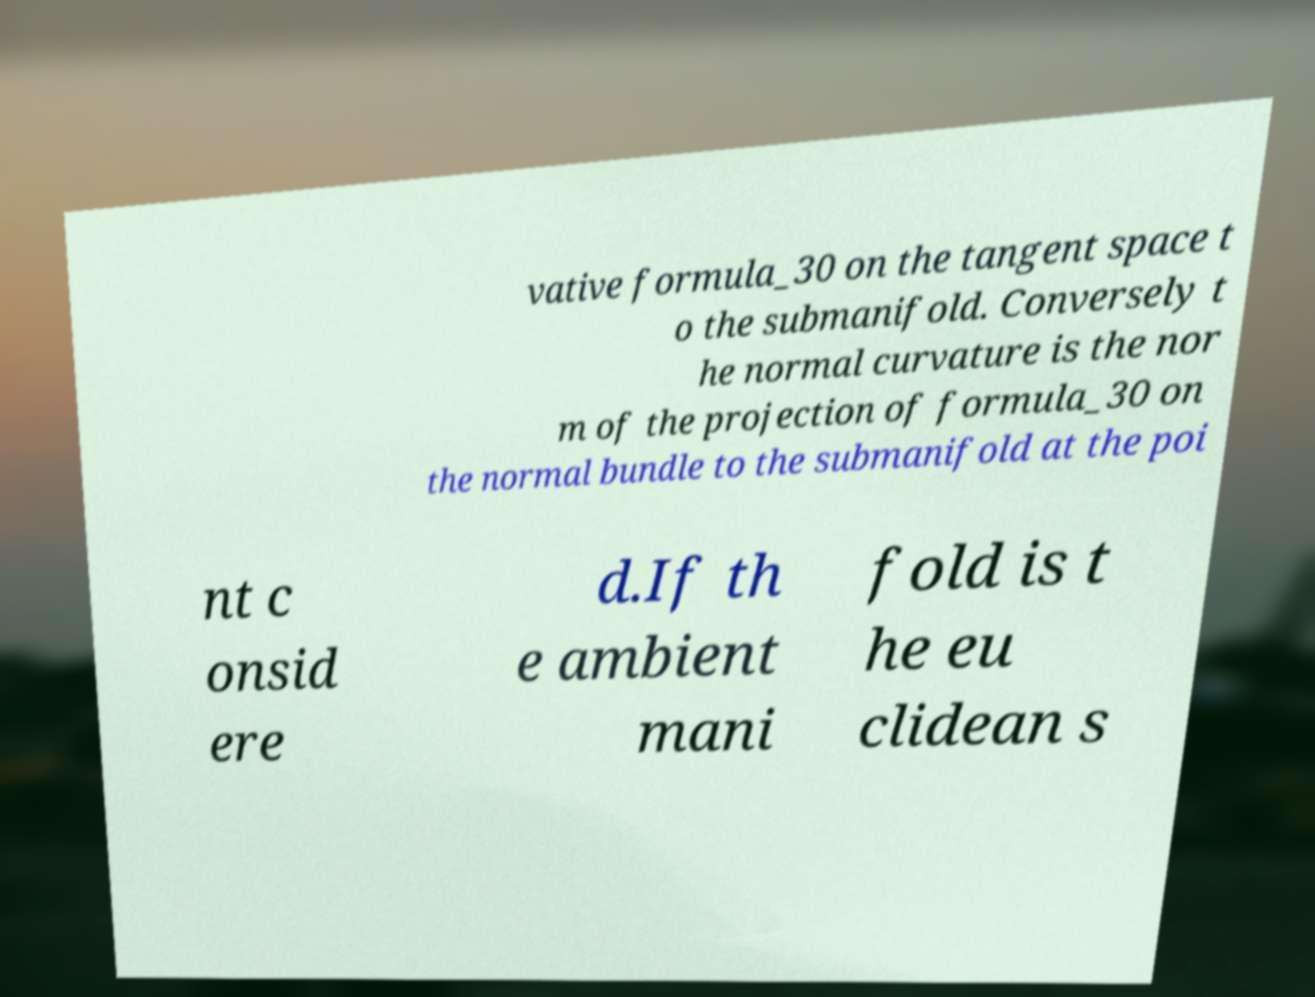Can you read and provide the text displayed in the image?This photo seems to have some interesting text. Can you extract and type it out for me? vative formula_30 on the tangent space t o the submanifold. Conversely t he normal curvature is the nor m of the projection of formula_30 on the normal bundle to the submanifold at the poi nt c onsid ere d.If th e ambient mani fold is t he eu clidean s 